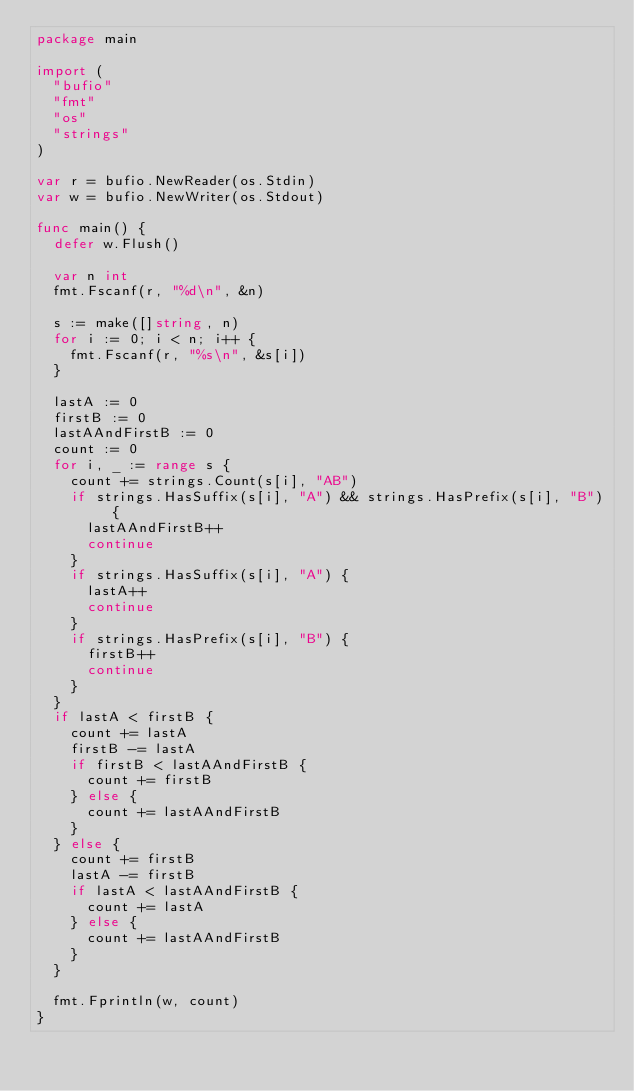<code> <loc_0><loc_0><loc_500><loc_500><_Go_>package main

import (
	"bufio"
	"fmt"
	"os"
	"strings"
)

var r = bufio.NewReader(os.Stdin)
var w = bufio.NewWriter(os.Stdout)

func main() {
	defer w.Flush()

	var n int
	fmt.Fscanf(r, "%d\n", &n)

	s := make([]string, n)
	for i := 0; i < n; i++ {
		fmt.Fscanf(r, "%s\n", &s[i])
	}

	lastA := 0
	firstB := 0
	lastAAndFirstB := 0
	count := 0
	for i, _ := range s {
		count += strings.Count(s[i], "AB")
		if strings.HasSuffix(s[i], "A") && strings.HasPrefix(s[i], "B") {
			lastAAndFirstB++
			continue
		}
		if strings.HasSuffix(s[i], "A") {
			lastA++
			continue
		}
		if strings.HasPrefix(s[i], "B") {
			firstB++
			continue
		}
	}
	if lastA < firstB {
		count += lastA
		firstB -= lastA
		if firstB < lastAAndFirstB {
			count += firstB
		} else {
			count += lastAAndFirstB
		}
	} else {
		count += firstB
		lastA -= firstB
		if lastA < lastAAndFirstB {
			count += lastA
		} else {
			count += lastAAndFirstB
		}
	}

	fmt.Fprintln(w, count)
}
</code> 